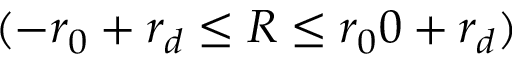<formula> <loc_0><loc_0><loc_500><loc_500>( - r _ { 0 } + r _ { d } \leq R \leq r _ { 0 } { 0 } + r _ { d } )</formula> 